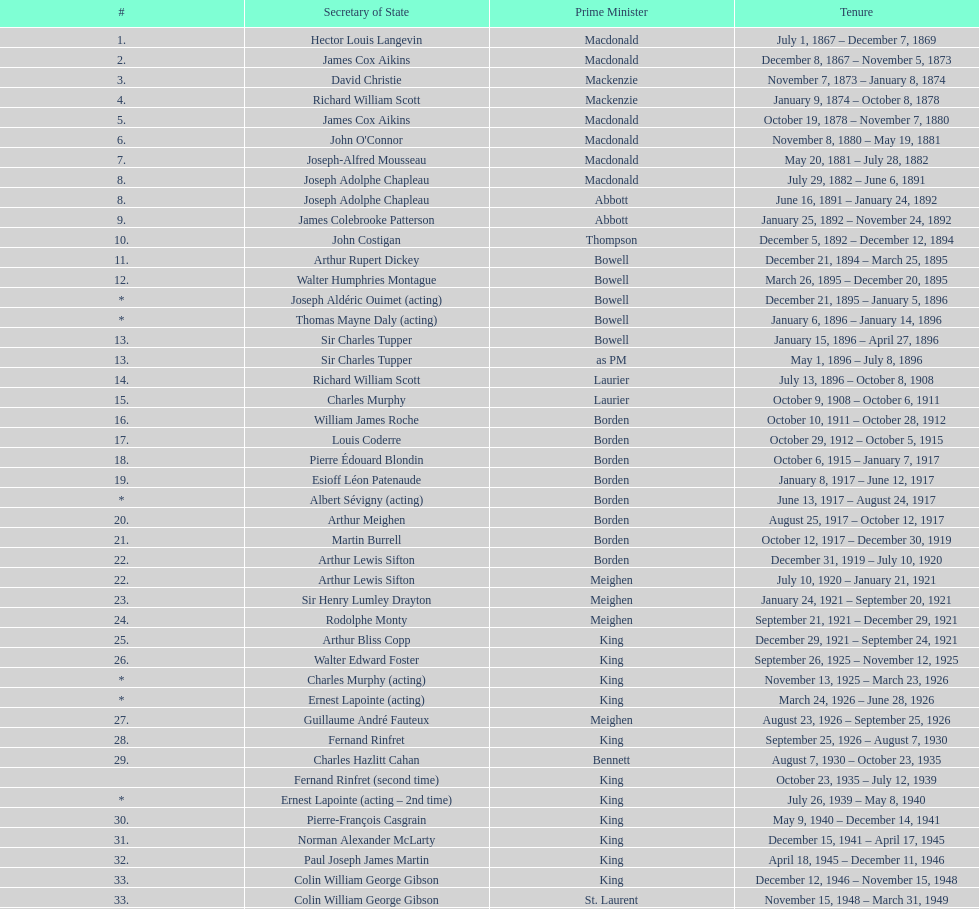Which secretary of state had the distinction of serving under both prime minister laurier and prime minister king? Charles Murphy. 